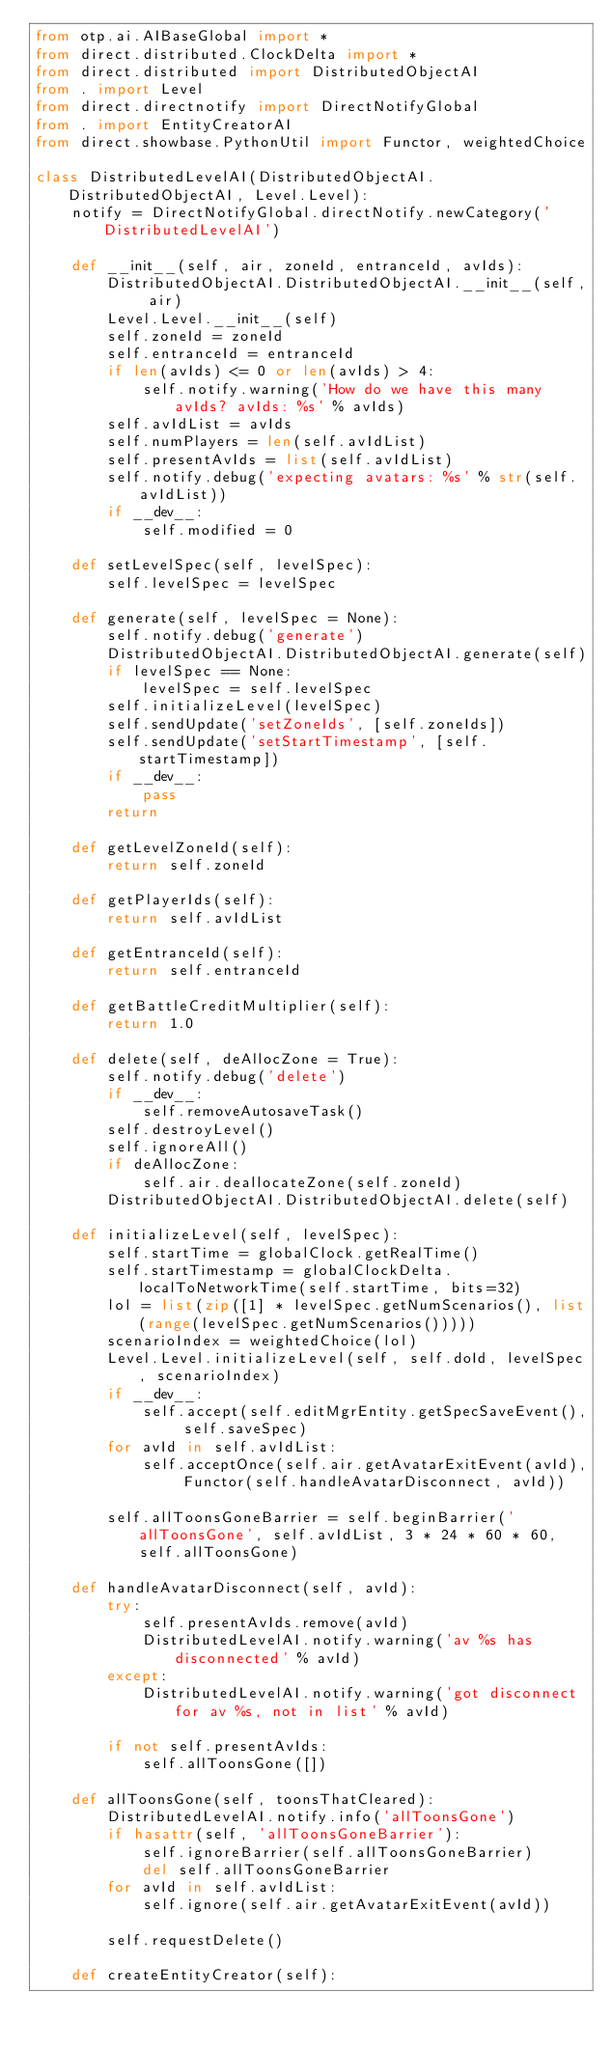Convert code to text. <code><loc_0><loc_0><loc_500><loc_500><_Python_>from otp.ai.AIBaseGlobal import *
from direct.distributed.ClockDelta import *
from direct.distributed import DistributedObjectAI
from . import Level
from direct.directnotify import DirectNotifyGlobal
from . import EntityCreatorAI
from direct.showbase.PythonUtil import Functor, weightedChoice

class DistributedLevelAI(DistributedObjectAI.DistributedObjectAI, Level.Level):
    notify = DirectNotifyGlobal.directNotify.newCategory('DistributedLevelAI')

    def __init__(self, air, zoneId, entranceId, avIds):
        DistributedObjectAI.DistributedObjectAI.__init__(self, air)
        Level.Level.__init__(self)
        self.zoneId = zoneId
        self.entranceId = entranceId
        if len(avIds) <= 0 or len(avIds) > 4:
            self.notify.warning('How do we have this many avIds? avIds: %s' % avIds)
        self.avIdList = avIds
        self.numPlayers = len(self.avIdList)
        self.presentAvIds = list(self.avIdList)
        self.notify.debug('expecting avatars: %s' % str(self.avIdList))
        if __dev__:
            self.modified = 0

    def setLevelSpec(self, levelSpec):
        self.levelSpec = levelSpec

    def generate(self, levelSpec = None):
        self.notify.debug('generate')
        DistributedObjectAI.DistributedObjectAI.generate(self)
        if levelSpec == None:
            levelSpec = self.levelSpec
        self.initializeLevel(levelSpec)
        self.sendUpdate('setZoneIds', [self.zoneIds])
        self.sendUpdate('setStartTimestamp', [self.startTimestamp])
        if __dev__:
            pass
        return

    def getLevelZoneId(self):
        return self.zoneId

    def getPlayerIds(self):
        return self.avIdList

    def getEntranceId(self):
        return self.entranceId

    def getBattleCreditMultiplier(self):
        return 1.0

    def delete(self, deAllocZone = True):
        self.notify.debug('delete')
        if __dev__:
            self.removeAutosaveTask()
        self.destroyLevel()
        self.ignoreAll()
        if deAllocZone:
            self.air.deallocateZone(self.zoneId)
        DistributedObjectAI.DistributedObjectAI.delete(self)

    def initializeLevel(self, levelSpec):
        self.startTime = globalClock.getRealTime()
        self.startTimestamp = globalClockDelta.localToNetworkTime(self.startTime, bits=32)
        lol = list(zip([1] * levelSpec.getNumScenarios(), list(range(levelSpec.getNumScenarios()))))
        scenarioIndex = weightedChoice(lol)
        Level.Level.initializeLevel(self, self.doId, levelSpec, scenarioIndex)
        if __dev__:
            self.accept(self.editMgrEntity.getSpecSaveEvent(), self.saveSpec)
        for avId in self.avIdList:
            self.acceptOnce(self.air.getAvatarExitEvent(avId), Functor(self.handleAvatarDisconnect, avId))

        self.allToonsGoneBarrier = self.beginBarrier('allToonsGone', self.avIdList, 3 * 24 * 60 * 60, self.allToonsGone)

    def handleAvatarDisconnect(self, avId):
        try:
            self.presentAvIds.remove(avId)
            DistributedLevelAI.notify.warning('av %s has disconnected' % avId)
        except:
            DistributedLevelAI.notify.warning('got disconnect for av %s, not in list' % avId)

        if not self.presentAvIds:
            self.allToonsGone([])

    def allToonsGone(self, toonsThatCleared):
        DistributedLevelAI.notify.info('allToonsGone')
        if hasattr(self, 'allToonsGoneBarrier'):
            self.ignoreBarrier(self.allToonsGoneBarrier)
            del self.allToonsGoneBarrier
        for avId in self.avIdList:
            self.ignore(self.air.getAvatarExitEvent(avId))

        self.requestDelete()

    def createEntityCreator(self):</code> 